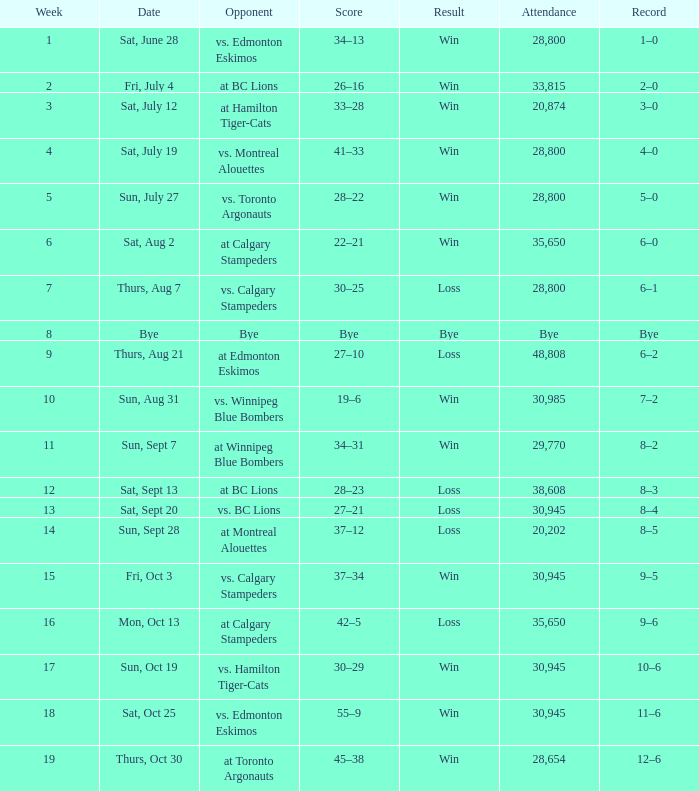What was the date of the game with an attendance of 20,874 fans? Sat, July 12. 